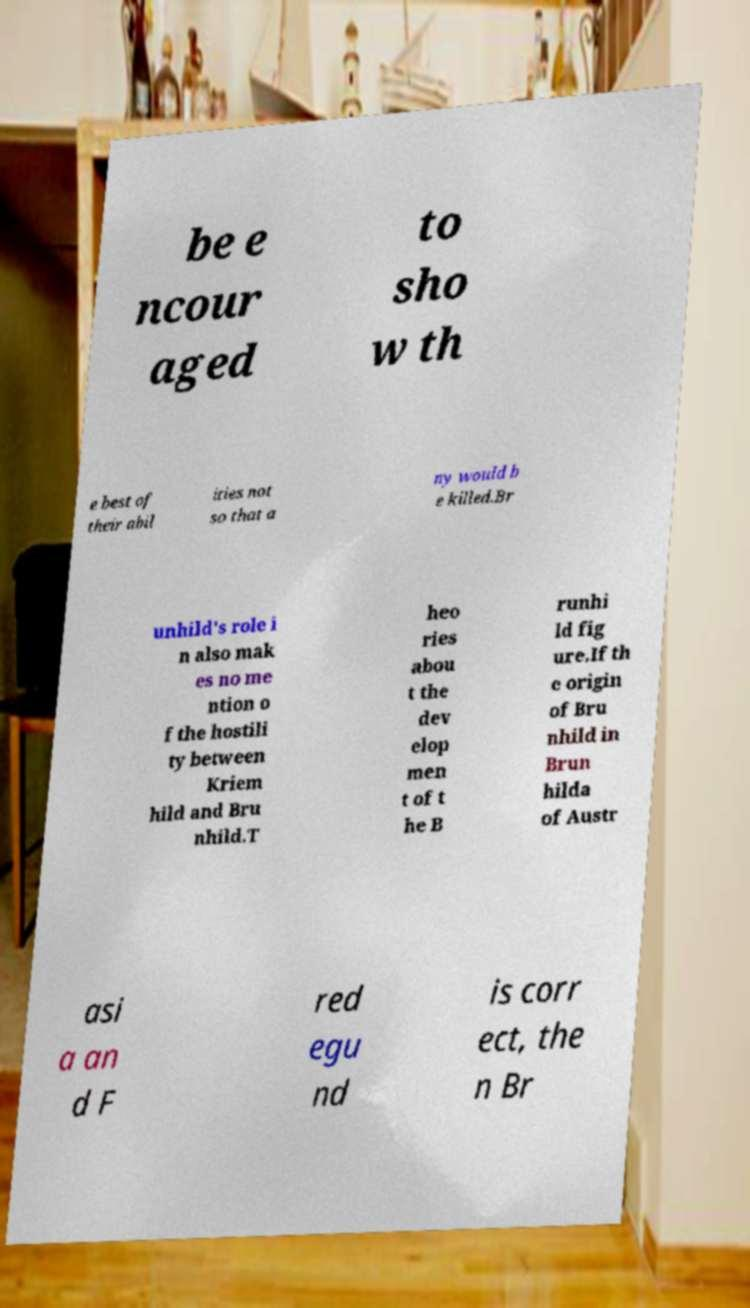I need the written content from this picture converted into text. Can you do that? be e ncour aged to sho w th e best of their abil ities not so that a ny would b e killed.Br unhild's role i n also mak es no me ntion o f the hostili ty between Kriem hild and Bru nhild.T heo ries abou t the dev elop men t of t he B runhi ld fig ure.If th e origin of Bru nhild in Brun hilda of Austr asi a an d F red egu nd is corr ect, the n Br 